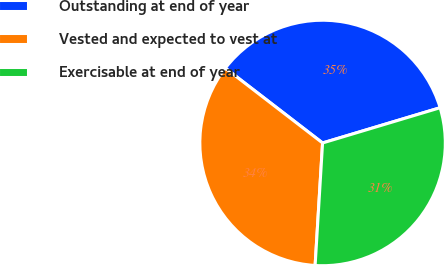<chart> <loc_0><loc_0><loc_500><loc_500><pie_chart><fcel>Outstanding at end of year<fcel>Vested and expected to vest at<fcel>Exercisable at end of year<nl><fcel>34.92%<fcel>34.47%<fcel>30.6%<nl></chart> 